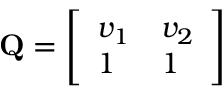Convert formula to latex. <formula><loc_0><loc_0><loc_500><loc_500>\begin{array} { r } { Q = \left [ \begin{array} { l l } { v _ { 1 } } & { v _ { 2 } } \\ { 1 } & { 1 } \end{array} \right ] } \end{array}</formula> 